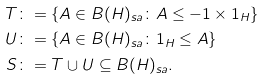Convert formula to latex. <formula><loc_0><loc_0><loc_500><loc_500>T \colon & = \{ A \in B ( H ) _ { s a } \colon A \leq - 1 \times 1 _ { H } \} \\ U \colon & = \{ A \in B ( H ) _ { s a } \colon 1 _ { H } \leq A \} \\ S \colon & = T \cup U \subseteq B ( H ) _ { s a } .</formula> 